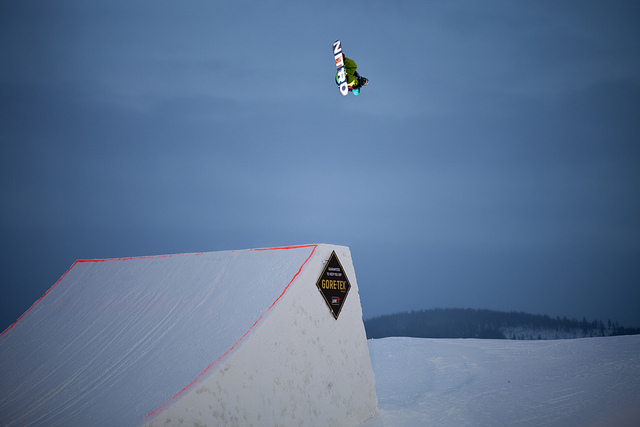Read and extract the text from this image. GORETEC 